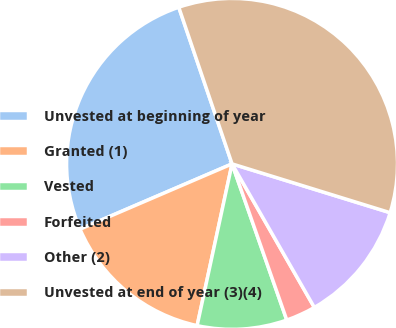Convert chart to OTSL. <chart><loc_0><loc_0><loc_500><loc_500><pie_chart><fcel>Unvested at beginning of year<fcel>Granted (1)<fcel>Vested<fcel>Forfeited<fcel>Other (2)<fcel>Unvested at end of year (3)(4)<nl><fcel>26.24%<fcel>15.16%<fcel>8.75%<fcel>2.92%<fcel>11.95%<fcel>34.99%<nl></chart> 